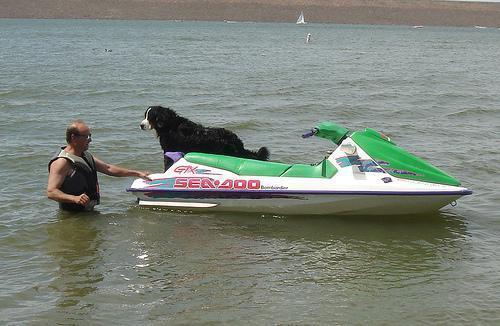How many sailboats are visible in the background?
Give a very brief answer. 1. 